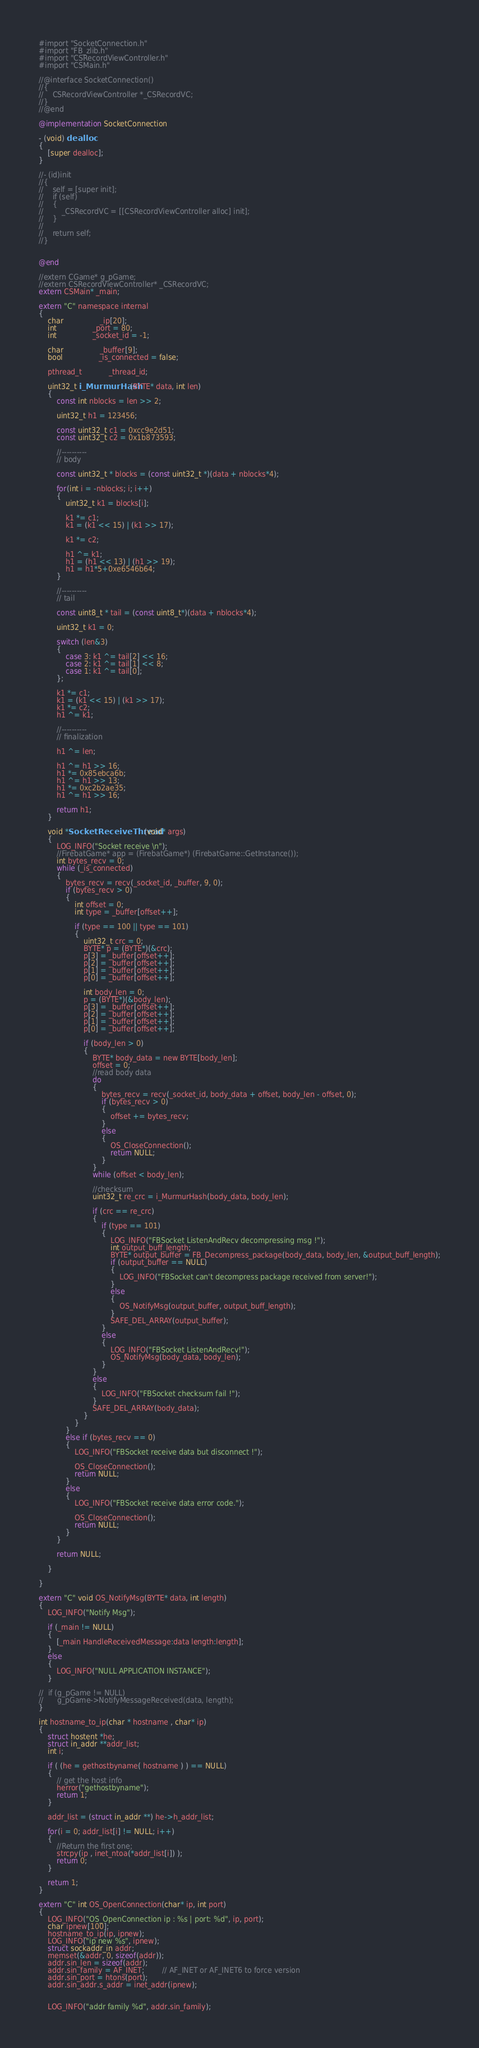<code> <loc_0><loc_0><loc_500><loc_500><_ObjectiveC_>
#import "SocketConnection.h"
#import "FB_zlib.h"
#import "CSRecordViewController.h"
#import "CSMain.h"

//@interface SocketConnection()
//{
//    CSRecordViewController *_CSRecordVC;
//}
//@end

@implementation SocketConnection

- (void) dealloc
{
	[super dealloc];
}

//- (id)init
//{
//    self = [super init];
//    if (self)
//    {
//        _CSRecordVC = [[CSRecordViewController alloc] init];
//    }
//    
//    return self;
//}


@end

//extern CGame* g_pGame;
//extern CSRecordViewController* _CSRecordVC;
extern CSMain* _main;

extern "C" namespace internal
{
	char 				_ip[20];
	int 				_port = 80;
	int 				_socket_id = -1;
		
	char				_buffer[9];
	bool				_is_connected = false;

	pthread_t			_thread_id;	
	
	uint32_t i_MurmurHash(BYTE* data, int len)
	{
		const int nblocks = len >> 2;
		
		uint32_t h1 = 123456;
		
		const uint32_t c1 = 0xcc9e2d51;
		const uint32_t c2 = 0x1b873593;
		
		//----------
		// body
		
		const uint32_t * blocks = (const uint32_t *)(data + nblocks*4);
		
		for(int i = -nblocks; i; i++)
		{
			uint32_t k1 = blocks[i];
			
			k1 *= c1;
			k1 = (k1 << 15) | (k1 >> 17);
			
			k1 *= c2;
			
			h1 ^= k1;
			h1 = (h1 << 13) | (h1 >> 19);
			h1 = h1*5+0xe6546b64;
		}
		
		//----------
		// tail
		
		const uint8_t * tail = (const uint8_t*)(data + nblocks*4);
		
		uint32_t k1 = 0;
		
		switch (len&3)
		{
			case 3: k1 ^= tail[2] << 16;
			case 2: k1 ^= tail[1] << 8;
			case 1: k1 ^= tail[0];
		};
		
		k1 *= c1;
		k1 = (k1 << 15) | (k1 >> 17);
		k1 *= c2;
		h1 ^= k1;
		
		//----------
		// finalization
		
		h1 ^= len;
		
		h1 ^= h1 >> 16;
		h1 *= 0x85ebca6b;
		h1 ^= h1 >> 13;
		h1 *= 0xc2b2ae35;
		h1 ^= h1 >> 16;
		
		return h1;
	}
	
	void *SocketReceiveThread(void* args)
	{
        LOG_INFO("Socket receive \n");
		//FirebatGame* app = (FirebatGame*) (FirebatGame::GetInstance());
		int bytes_recv = 0;
		while (_is_connected)
		{
			bytes_recv = recv(_socket_id, _buffer, 9, 0);
			if (bytes_recv > 0)
			{
				int offset = 0;
				int type = _buffer[offset++];
				
				if (type == 100 || type == 101)
				{
					uint32_t crc = 0;
					BYTE* p = (BYTE*)(&crc);
					p[3] = _buffer[offset++];
					p[2] = _buffer[offset++];
					p[1] = _buffer[offset++];
					p[0] = _buffer[offset++];
					
					int body_len = 0;
					p = (BYTE*)(&body_len);
					p[3] = _buffer[offset++];
					p[2] = _buffer[offset++];
					p[1] = _buffer[offset++];
					p[0] = _buffer[offset++];
					
					if (body_len > 0)
					{
						BYTE* body_data = new BYTE[body_len];
						offset = 0;
						//read body data
						do
						{
							bytes_recv = recv(_socket_id, body_data + offset, body_len - offset, 0);
							if (bytes_recv > 0)
							{
								offset += bytes_recv;
							}
							else
							{
								OS_CloseConnection();
								return NULL;
							}
						}
						while (offset < body_len);
						
						//checksum
						uint32_t re_crc = i_MurmurHash(body_data, body_len);
						
						if (crc == re_crc)
						{
							if (type == 101)
							{
								LOG_INFO("FBSocket ListenAndRecv decompressing msg !");
								int output_buff_length;
								BYTE* output_buffer = FB_Decompress_package(body_data, body_len, &output_buff_length);
								if (output_buffer == NULL)
								{
									LOG_INFO("FBSocket can't decompress package received from server!");
								}
								else
								{
									OS_NotifyMsg(output_buffer, output_buff_length);
								}
								SAFE_DEL_ARRAY(output_buffer);
							}
							else
							{
								LOG_INFO("FBSocket ListenAndRecv!");
								OS_NotifyMsg(body_data, body_len);
							}
						}
						else
						{
							LOG_INFO("FBSocket checksum fail !");
						}
						SAFE_DEL_ARRAY(body_data);
					}
				}
			}
			else if (bytes_recv == 0)
			{
				LOG_INFO("FBSocket receive data but disconnect !");
				
				OS_CloseConnection();
				return NULL;
			}
			else
			{
				LOG_INFO("FBSocket receive data error code.");
				
				OS_CloseConnection();
				return NULL;
			}
		}
		
		return NULL;
	
	}

}

extern "C" void OS_NotifyMsg(BYTE* data, int length)
{
    LOG_INFO("Notify Msg");
    
    if (_main != NULL)
    {
        [_main HandleReceivedMessage:data length:length]; 
    }
    else
    {
        LOG_INFO("NULL APPLICATION INSTANCE");
    }

//	if (g_pGame != NULL)
//		g_pGame->NotifyMessageReceived(data, length);
}

int hostname_to_ip(char * hostname , char* ip)
{
    struct hostent *he;
    struct in_addr **addr_list;
    int i;
         
    if ( (he = gethostbyname( hostname ) ) == NULL) 
    {
        // get the host info
        herror("gethostbyname");
        return 1;
    }
 
    addr_list = (struct in_addr **) he->h_addr_list;
     
    for(i = 0; addr_list[i] != NULL; i++) 
    {
        //Return the first one;
        strcpy(ip , inet_ntoa(*addr_list[i]) );
        return 0;
    }
     
    return 1;
}

extern "C" int OS_OpenConnection(char* ip, int port)
{
	LOG_INFO("OS_OpenConnection ip : %s | port: %d", ip, port);
	char ipnew[100];
    hostname_to_ip(ip, ipnew);
	LOG_INFO("ip new %s", ipnew);
	struct sockaddr_in addr;
	memset(&addr, 0, sizeof(addr));
    addr.sin_len = sizeof(addr);
	addr.sin_family = AF_INET; 		// AF_INET or AF_INET6 to force version
	addr.sin_port = htons(port);
    addr.sin_addr.s_addr = inet_addr(ipnew);
	
	
    LOG_INFO("addr family %d", addr.sin_family);</code> 